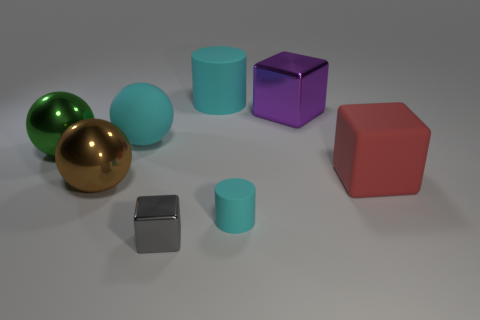Are there fewer large metallic balls to the right of the green shiny sphere than large brown balls right of the purple cube?
Your answer should be compact. No. How many other objects are there of the same material as the brown object?
Make the answer very short. 3. There is a cyan cylinder that is the same size as the purple metal object; what is its material?
Ensure brevity in your answer.  Rubber. How many cyan things are either metallic objects or large shiny balls?
Your response must be concise. 0. There is a large ball that is both behind the red matte block and to the right of the green thing; what color is it?
Your response must be concise. Cyan. Is the cube that is on the left side of the big purple cube made of the same material as the big thing that is on the left side of the large brown thing?
Offer a very short reply. Yes. Is the number of cyan matte cylinders behind the big red matte cube greater than the number of small cyan cylinders behind the large brown shiny ball?
Your answer should be compact. Yes. There is a cyan rubber object that is the same size as the gray metallic block; what is its shape?
Ensure brevity in your answer.  Cylinder. What number of objects are either green things or gray things that are in front of the purple shiny block?
Provide a succinct answer. 2. Does the small block have the same color as the large cylinder?
Offer a very short reply. No. 